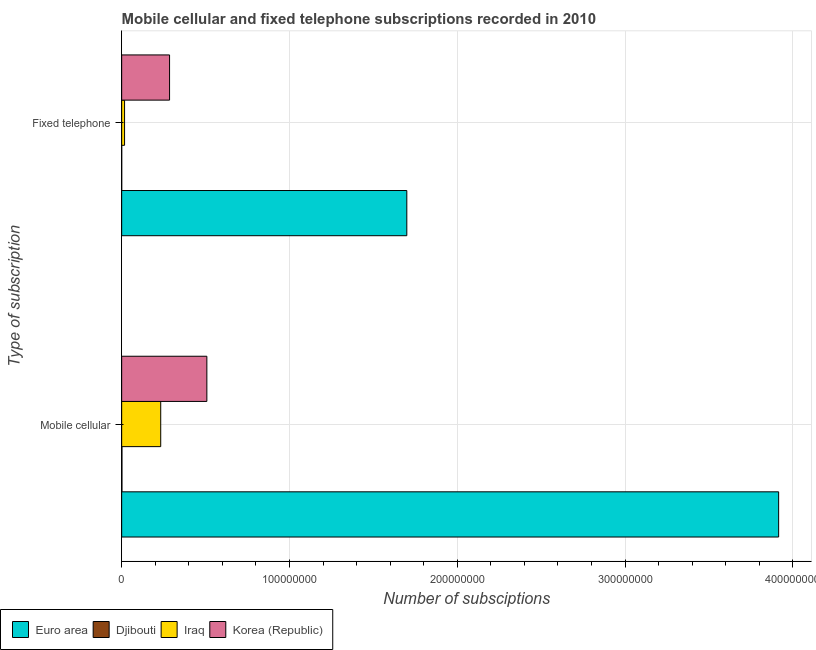How many different coloured bars are there?
Ensure brevity in your answer.  4. How many groups of bars are there?
Keep it short and to the point. 2. Are the number of bars per tick equal to the number of legend labels?
Provide a succinct answer. Yes. How many bars are there on the 1st tick from the top?
Make the answer very short. 4. How many bars are there on the 1st tick from the bottom?
Your answer should be very brief. 4. What is the label of the 2nd group of bars from the top?
Your answer should be very brief. Mobile cellular. What is the number of fixed telephone subscriptions in Korea (Republic)?
Provide a short and direct response. 2.85e+07. Across all countries, what is the maximum number of fixed telephone subscriptions?
Offer a very short reply. 1.70e+08. Across all countries, what is the minimum number of mobile cellular subscriptions?
Your response must be concise. 1.66e+05. In which country was the number of mobile cellular subscriptions maximum?
Offer a terse response. Euro area. In which country was the number of mobile cellular subscriptions minimum?
Your answer should be compact. Djibouti. What is the total number of fixed telephone subscriptions in the graph?
Ensure brevity in your answer.  2.00e+08. What is the difference between the number of fixed telephone subscriptions in Djibouti and that in Korea (Republic)?
Make the answer very short. -2.85e+07. What is the difference between the number of fixed telephone subscriptions in Iraq and the number of mobile cellular subscriptions in Euro area?
Keep it short and to the point. -3.90e+08. What is the average number of mobile cellular subscriptions per country?
Ensure brevity in your answer.  1.16e+08. What is the difference between the number of mobile cellular subscriptions and number of fixed telephone subscriptions in Djibouti?
Ensure brevity in your answer.  1.47e+05. What is the ratio of the number of mobile cellular subscriptions in Korea (Republic) to that in Iraq?
Provide a succinct answer. 2.18. In how many countries, is the number of fixed telephone subscriptions greater than the average number of fixed telephone subscriptions taken over all countries?
Ensure brevity in your answer.  1. What does the 3rd bar from the top in Mobile cellular represents?
Your response must be concise. Djibouti. How many countries are there in the graph?
Offer a terse response. 4. Are the values on the major ticks of X-axis written in scientific E-notation?
Give a very brief answer. No. Does the graph contain any zero values?
Your response must be concise. No. Does the graph contain grids?
Your answer should be compact. Yes. Where does the legend appear in the graph?
Your answer should be very brief. Bottom left. How many legend labels are there?
Your answer should be very brief. 4. What is the title of the graph?
Provide a short and direct response. Mobile cellular and fixed telephone subscriptions recorded in 2010. Does "Saudi Arabia" appear as one of the legend labels in the graph?
Provide a succinct answer. No. What is the label or title of the X-axis?
Keep it short and to the point. Number of subsciptions. What is the label or title of the Y-axis?
Offer a terse response. Type of subscription. What is the Number of subsciptions of Euro area in Mobile cellular?
Make the answer very short. 3.92e+08. What is the Number of subsciptions of Djibouti in Mobile cellular?
Provide a short and direct response. 1.66e+05. What is the Number of subsciptions of Iraq in Mobile cellular?
Make the answer very short. 2.33e+07. What is the Number of subsciptions of Korea (Republic) in Mobile cellular?
Give a very brief answer. 5.08e+07. What is the Number of subsciptions of Euro area in Fixed telephone?
Provide a short and direct response. 1.70e+08. What is the Number of subsciptions of Djibouti in Fixed telephone?
Provide a short and direct response. 1.85e+04. What is the Number of subsciptions in Iraq in Fixed telephone?
Offer a terse response. 1.72e+06. What is the Number of subsciptions of Korea (Republic) in Fixed telephone?
Give a very brief answer. 2.85e+07. Across all Type of subscription, what is the maximum Number of subsciptions in Euro area?
Provide a succinct answer. 3.92e+08. Across all Type of subscription, what is the maximum Number of subsciptions of Djibouti?
Keep it short and to the point. 1.66e+05. Across all Type of subscription, what is the maximum Number of subsciptions in Iraq?
Your answer should be compact. 2.33e+07. Across all Type of subscription, what is the maximum Number of subsciptions of Korea (Republic)?
Your answer should be compact. 5.08e+07. Across all Type of subscription, what is the minimum Number of subsciptions of Euro area?
Offer a terse response. 1.70e+08. Across all Type of subscription, what is the minimum Number of subsciptions of Djibouti?
Your response must be concise. 1.85e+04. Across all Type of subscription, what is the minimum Number of subsciptions in Iraq?
Offer a terse response. 1.72e+06. Across all Type of subscription, what is the minimum Number of subsciptions of Korea (Republic)?
Ensure brevity in your answer.  2.85e+07. What is the total Number of subsciptions in Euro area in the graph?
Ensure brevity in your answer.  5.61e+08. What is the total Number of subsciptions in Djibouti in the graph?
Your answer should be compact. 1.84e+05. What is the total Number of subsciptions of Iraq in the graph?
Ensure brevity in your answer.  2.50e+07. What is the total Number of subsciptions in Korea (Republic) in the graph?
Offer a terse response. 7.93e+07. What is the difference between the Number of subsciptions of Euro area in Mobile cellular and that in Fixed telephone?
Ensure brevity in your answer.  2.22e+08. What is the difference between the Number of subsciptions in Djibouti in Mobile cellular and that in Fixed telephone?
Your response must be concise. 1.47e+05. What is the difference between the Number of subsciptions in Iraq in Mobile cellular and that in Fixed telephone?
Provide a short and direct response. 2.15e+07. What is the difference between the Number of subsciptions of Korea (Republic) in Mobile cellular and that in Fixed telephone?
Give a very brief answer. 2.22e+07. What is the difference between the Number of subsciptions of Euro area in Mobile cellular and the Number of subsciptions of Djibouti in Fixed telephone?
Provide a short and direct response. 3.92e+08. What is the difference between the Number of subsciptions in Euro area in Mobile cellular and the Number of subsciptions in Iraq in Fixed telephone?
Ensure brevity in your answer.  3.90e+08. What is the difference between the Number of subsciptions of Euro area in Mobile cellular and the Number of subsciptions of Korea (Republic) in Fixed telephone?
Your response must be concise. 3.63e+08. What is the difference between the Number of subsciptions of Djibouti in Mobile cellular and the Number of subsciptions of Iraq in Fixed telephone?
Make the answer very short. -1.55e+06. What is the difference between the Number of subsciptions of Djibouti in Mobile cellular and the Number of subsciptions of Korea (Republic) in Fixed telephone?
Keep it short and to the point. -2.84e+07. What is the difference between the Number of subsciptions in Iraq in Mobile cellular and the Number of subsciptions in Korea (Republic) in Fixed telephone?
Provide a short and direct response. -5.28e+06. What is the average Number of subsciptions in Euro area per Type of subscription?
Your answer should be compact. 2.81e+08. What is the average Number of subsciptions of Djibouti per Type of subscription?
Provide a short and direct response. 9.20e+04. What is the average Number of subsciptions of Iraq per Type of subscription?
Ensure brevity in your answer.  1.25e+07. What is the average Number of subsciptions in Korea (Republic) per Type of subscription?
Offer a very short reply. 3.97e+07. What is the difference between the Number of subsciptions of Euro area and Number of subsciptions of Djibouti in Mobile cellular?
Give a very brief answer. 3.91e+08. What is the difference between the Number of subsciptions of Euro area and Number of subsciptions of Iraq in Mobile cellular?
Your answer should be very brief. 3.68e+08. What is the difference between the Number of subsciptions in Euro area and Number of subsciptions in Korea (Republic) in Mobile cellular?
Ensure brevity in your answer.  3.41e+08. What is the difference between the Number of subsciptions of Djibouti and Number of subsciptions of Iraq in Mobile cellular?
Provide a succinct answer. -2.31e+07. What is the difference between the Number of subsciptions in Djibouti and Number of subsciptions in Korea (Republic) in Mobile cellular?
Make the answer very short. -5.06e+07. What is the difference between the Number of subsciptions of Iraq and Number of subsciptions of Korea (Republic) in Mobile cellular?
Provide a short and direct response. -2.75e+07. What is the difference between the Number of subsciptions in Euro area and Number of subsciptions in Djibouti in Fixed telephone?
Your answer should be compact. 1.70e+08. What is the difference between the Number of subsciptions of Euro area and Number of subsciptions of Iraq in Fixed telephone?
Give a very brief answer. 1.68e+08. What is the difference between the Number of subsciptions in Euro area and Number of subsciptions in Korea (Republic) in Fixed telephone?
Your answer should be very brief. 1.41e+08. What is the difference between the Number of subsciptions in Djibouti and Number of subsciptions in Iraq in Fixed telephone?
Ensure brevity in your answer.  -1.70e+06. What is the difference between the Number of subsciptions of Djibouti and Number of subsciptions of Korea (Republic) in Fixed telephone?
Offer a terse response. -2.85e+07. What is the difference between the Number of subsciptions in Iraq and Number of subsciptions in Korea (Republic) in Fixed telephone?
Provide a succinct answer. -2.68e+07. What is the ratio of the Number of subsciptions of Euro area in Mobile cellular to that in Fixed telephone?
Offer a terse response. 2.3. What is the ratio of the Number of subsciptions of Djibouti in Mobile cellular to that in Fixed telephone?
Make the answer very short. 8.96. What is the ratio of the Number of subsciptions of Iraq in Mobile cellular to that in Fixed telephone?
Your response must be concise. 13.52. What is the ratio of the Number of subsciptions of Korea (Republic) in Mobile cellular to that in Fixed telephone?
Offer a very short reply. 1.78. What is the difference between the highest and the second highest Number of subsciptions in Euro area?
Offer a terse response. 2.22e+08. What is the difference between the highest and the second highest Number of subsciptions in Djibouti?
Your response must be concise. 1.47e+05. What is the difference between the highest and the second highest Number of subsciptions of Iraq?
Make the answer very short. 2.15e+07. What is the difference between the highest and the second highest Number of subsciptions in Korea (Republic)?
Ensure brevity in your answer.  2.22e+07. What is the difference between the highest and the lowest Number of subsciptions of Euro area?
Your response must be concise. 2.22e+08. What is the difference between the highest and the lowest Number of subsciptions in Djibouti?
Make the answer very short. 1.47e+05. What is the difference between the highest and the lowest Number of subsciptions in Iraq?
Provide a short and direct response. 2.15e+07. What is the difference between the highest and the lowest Number of subsciptions in Korea (Republic)?
Ensure brevity in your answer.  2.22e+07. 